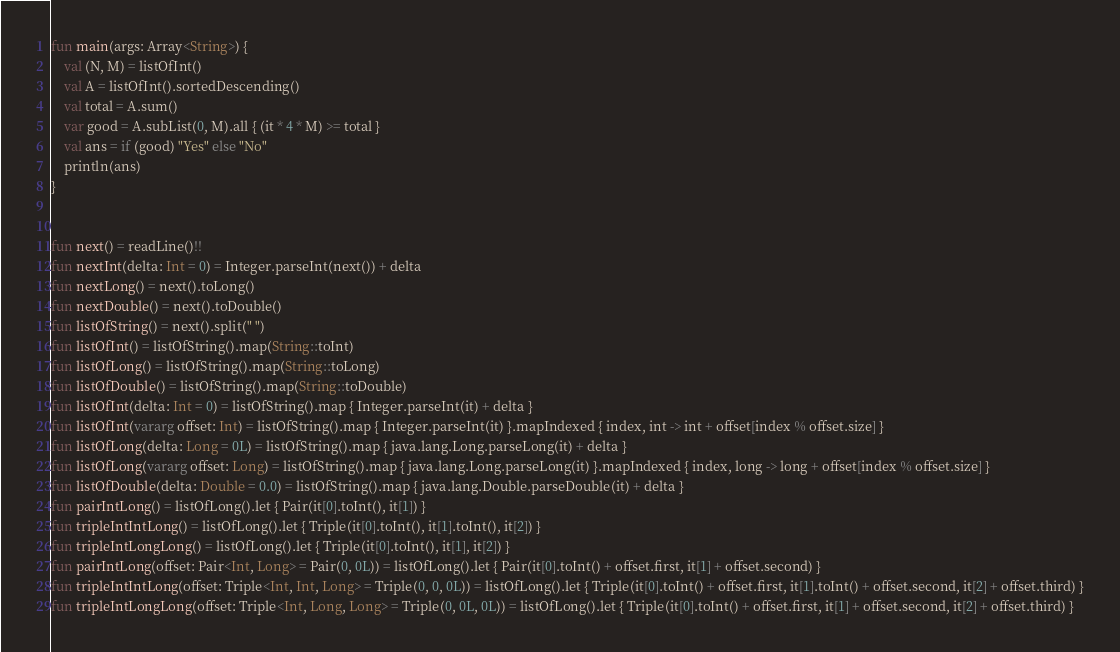Convert code to text. <code><loc_0><loc_0><loc_500><loc_500><_Kotlin_>fun main(args: Array<String>) {
    val (N, M) = listOfInt()
    val A = listOfInt().sortedDescending()
    val total = A.sum()
    var good = A.subList(0, M).all { (it * 4 * M) >= total }
    val ans = if (good) "Yes" else "No"
    println(ans)
}


fun next() = readLine()!!
fun nextInt(delta: Int = 0) = Integer.parseInt(next()) + delta
fun nextLong() = next().toLong()
fun nextDouble() = next().toDouble()
fun listOfString() = next().split(" ")
fun listOfInt() = listOfString().map(String::toInt)
fun listOfLong() = listOfString().map(String::toLong)
fun listOfDouble() = listOfString().map(String::toDouble)
fun listOfInt(delta: Int = 0) = listOfString().map { Integer.parseInt(it) + delta }
fun listOfInt(vararg offset: Int) = listOfString().map { Integer.parseInt(it) }.mapIndexed { index, int -> int + offset[index % offset.size] }
fun listOfLong(delta: Long = 0L) = listOfString().map { java.lang.Long.parseLong(it) + delta }
fun listOfLong(vararg offset: Long) = listOfString().map { java.lang.Long.parseLong(it) }.mapIndexed { index, long -> long + offset[index % offset.size] }
fun listOfDouble(delta: Double = 0.0) = listOfString().map { java.lang.Double.parseDouble(it) + delta }
fun pairIntLong() = listOfLong().let { Pair(it[0].toInt(), it[1]) }
fun tripleIntIntLong() = listOfLong().let { Triple(it[0].toInt(), it[1].toInt(), it[2]) }
fun tripleIntLongLong() = listOfLong().let { Triple(it[0].toInt(), it[1], it[2]) }
fun pairIntLong(offset: Pair<Int, Long> = Pair(0, 0L)) = listOfLong().let { Pair(it[0].toInt() + offset.first, it[1] + offset.second) }
fun tripleIntIntLong(offset: Triple<Int, Int, Long> = Triple(0, 0, 0L)) = listOfLong().let { Triple(it[0].toInt() + offset.first, it[1].toInt() + offset.second, it[2] + offset.third) }
fun tripleIntLongLong(offset: Triple<Int, Long, Long> = Triple(0, 0L, 0L)) = listOfLong().let { Triple(it[0].toInt() + offset.first, it[1] + offset.second, it[2] + offset.third) }



</code> 